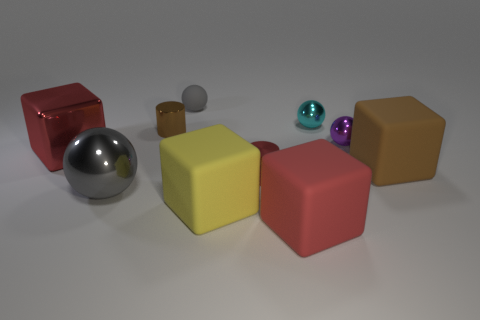Is the number of purple spheres greater than the number of tiny purple rubber blocks? Yes, indeed. Upon careful observation, it is clear that there are two purple spheres, whereas there are no visible purple rubber blocks at all. Therefore, the count of purple spheres is not only greater, but the purple blocks are completely absent in this scene. 